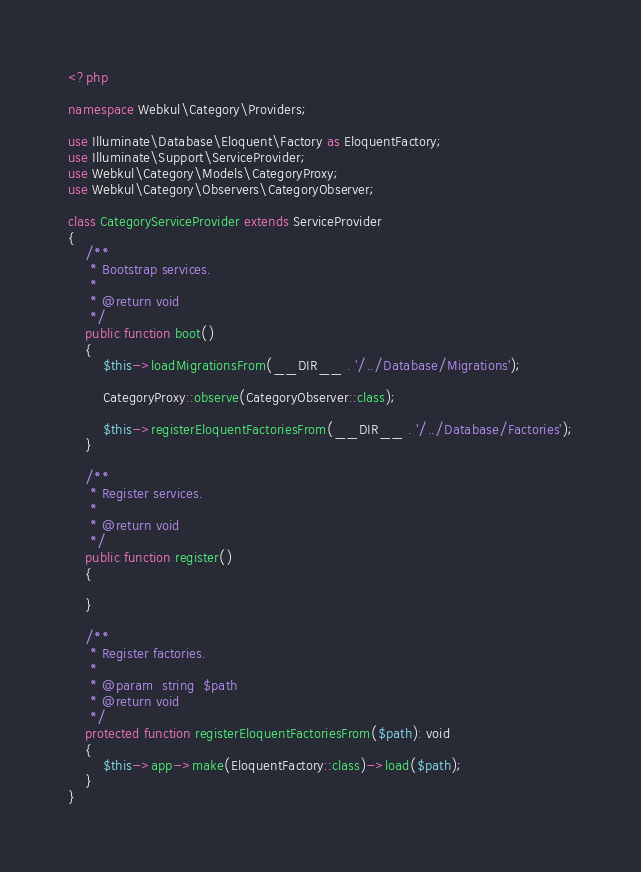Convert code to text. <code><loc_0><loc_0><loc_500><loc_500><_PHP_><?php

namespace Webkul\Category\Providers;

use Illuminate\Database\Eloquent\Factory as EloquentFactory;
use Illuminate\Support\ServiceProvider;
use Webkul\Category\Models\CategoryProxy;
use Webkul\Category\Observers\CategoryObserver;

class CategoryServiceProvider extends ServiceProvider
{
    /**
     * Bootstrap services.
     *
     * @return void
     */
    public function boot()
    {
        $this->loadMigrationsFrom(__DIR__ . '/../Database/Migrations');

        CategoryProxy::observe(CategoryObserver::class);

        $this->registerEloquentFactoriesFrom(__DIR__ . '/../Database/Factories');
    }

    /**
     * Register services.
     *
     * @return void
     */
    public function register()
    {

    }

    /**
     * Register factories.
     *
     * @param  string  $path
     * @return void
     */
    protected function registerEloquentFactoriesFrom($path): void
    {
        $this->app->make(EloquentFactory::class)->load($path);
    }
}</code> 